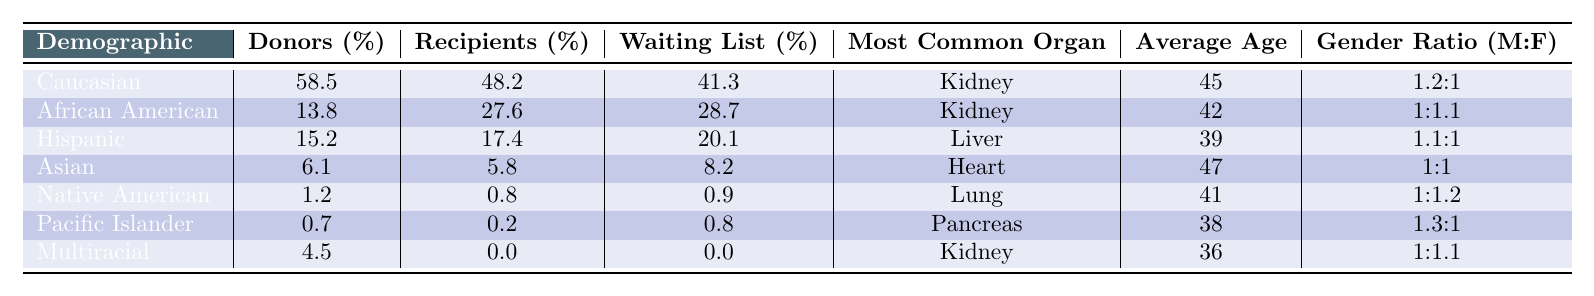What demographic has the highest percentage of organ donors? Looking at the "Donors (%)" column, Caucasian has the highest percentage at 58.5%.
Answer: Caucasian Which demographic has the lowest percentage of organ donors? The "Donors (%)" column shows that Pacific Islander has the lowest percentage at 0.7%.
Answer: Pacific Islander What organ is most commonly donated by Asian individuals? In the "Most Common Organ" column for Asian, it states "Heart."
Answer: Heart What is the average age of recipients for the Hispanic demographic? The "Average Age" for Hispanic in the table is listed as 39 years.
Answer: 39 How many demographics have a higher percentage of recipients than donors? By comparing the "Donors (%)" and "Recipients (%)" columns, only African American (13.8% donors vs. 27.6% recipients) and Hispanic (15.2% donors vs. 17.4% recipients) have higher recipient percentages than donor percentages. Thus, there are two such demographics.
Answer: 2 What is the gender ratio for Caucasian donors? The gender ratio for Caucasian in the "Gender Ratio (M:F)" column is listed as 1.2:1.
Answer: 1.2:1 Which demographic has the highest percentage on the waiting list? Looking at the "Waiting List (%)" column, Caucasian has the highest percentage at 41.3%.
Answer: Caucasian What is the average age of organ donors for Native American individuals? The "Average Age" for Native American in the table is 41 years.
Answer: 41 Is the percentage of Hispanic recipients higher or lower than that of Asian recipients? Hispanic recipients (%) is 17.4% while Asian recipients (%) is 5.8%, so Hispanic recipients are higher.
Answer: Higher If you sum the donor percentages of all demographics, what is the total? Adding all donor percentages: 58.5 + 13.8 + 15.2 + 6.1 + 1.2 + 0.7 + 4.5 = 100.
Answer: 100 